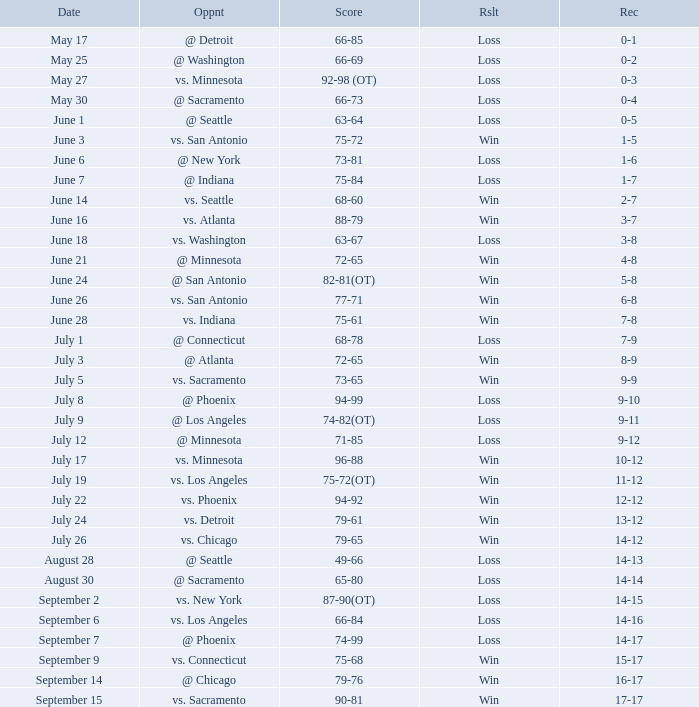What was the Result on May 30? Loss. 